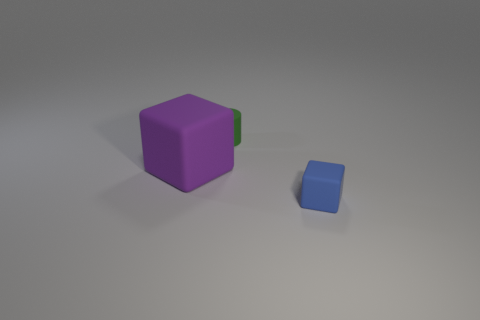Add 3 small blue blocks. How many objects exist? 6 Subtract all blocks. How many objects are left? 1 Add 2 cylinders. How many cylinders exist? 3 Subtract 0 red cylinders. How many objects are left? 3 Subtract all small blue matte objects. Subtract all matte cylinders. How many objects are left? 1 Add 1 tiny blue blocks. How many tiny blue blocks are left? 2 